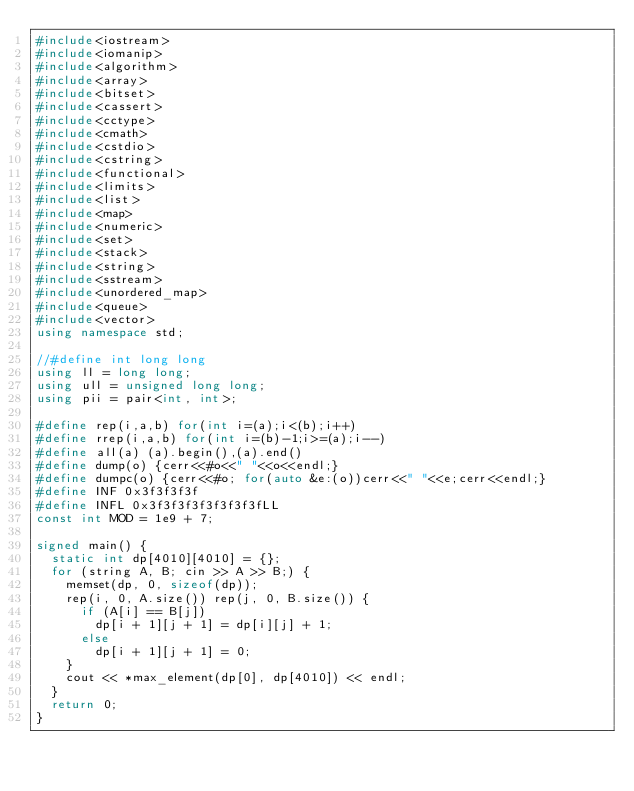Convert code to text. <code><loc_0><loc_0><loc_500><loc_500><_C++_>#include<iostream>
#include<iomanip>
#include<algorithm>
#include<array>
#include<bitset>
#include<cassert>
#include<cctype>
#include<cmath>
#include<cstdio>
#include<cstring>
#include<functional>
#include<limits>
#include<list>
#include<map>
#include<numeric>
#include<set>
#include<stack>
#include<string>
#include<sstream>
#include<unordered_map>
#include<queue>
#include<vector>
using namespace std;

//#define int long long
using ll = long long;
using ull = unsigned long long;
using pii = pair<int, int>;

#define rep(i,a,b) for(int i=(a);i<(b);i++)
#define rrep(i,a,b) for(int i=(b)-1;i>=(a);i--)
#define all(a) (a).begin(),(a).end()
#define dump(o) {cerr<<#o<<" "<<o<<endl;}
#define dumpc(o) {cerr<<#o; for(auto &e:(o))cerr<<" "<<e;cerr<<endl;}
#define INF 0x3f3f3f3f
#define INFL 0x3f3f3f3f3f3f3f3fLL
const int MOD = 1e9 + 7;

signed main() {
	static int dp[4010][4010] = {};
	for (string A, B; cin >> A >> B;) {
		memset(dp, 0, sizeof(dp));
		rep(i, 0, A.size()) rep(j, 0, B.size()) {
			if (A[i] == B[j])
				dp[i + 1][j + 1] = dp[i][j] + 1;
			else
				dp[i + 1][j + 1] = 0;
		}
		cout << *max_element(dp[0], dp[4010]) << endl;
	}
	return 0;
}</code> 